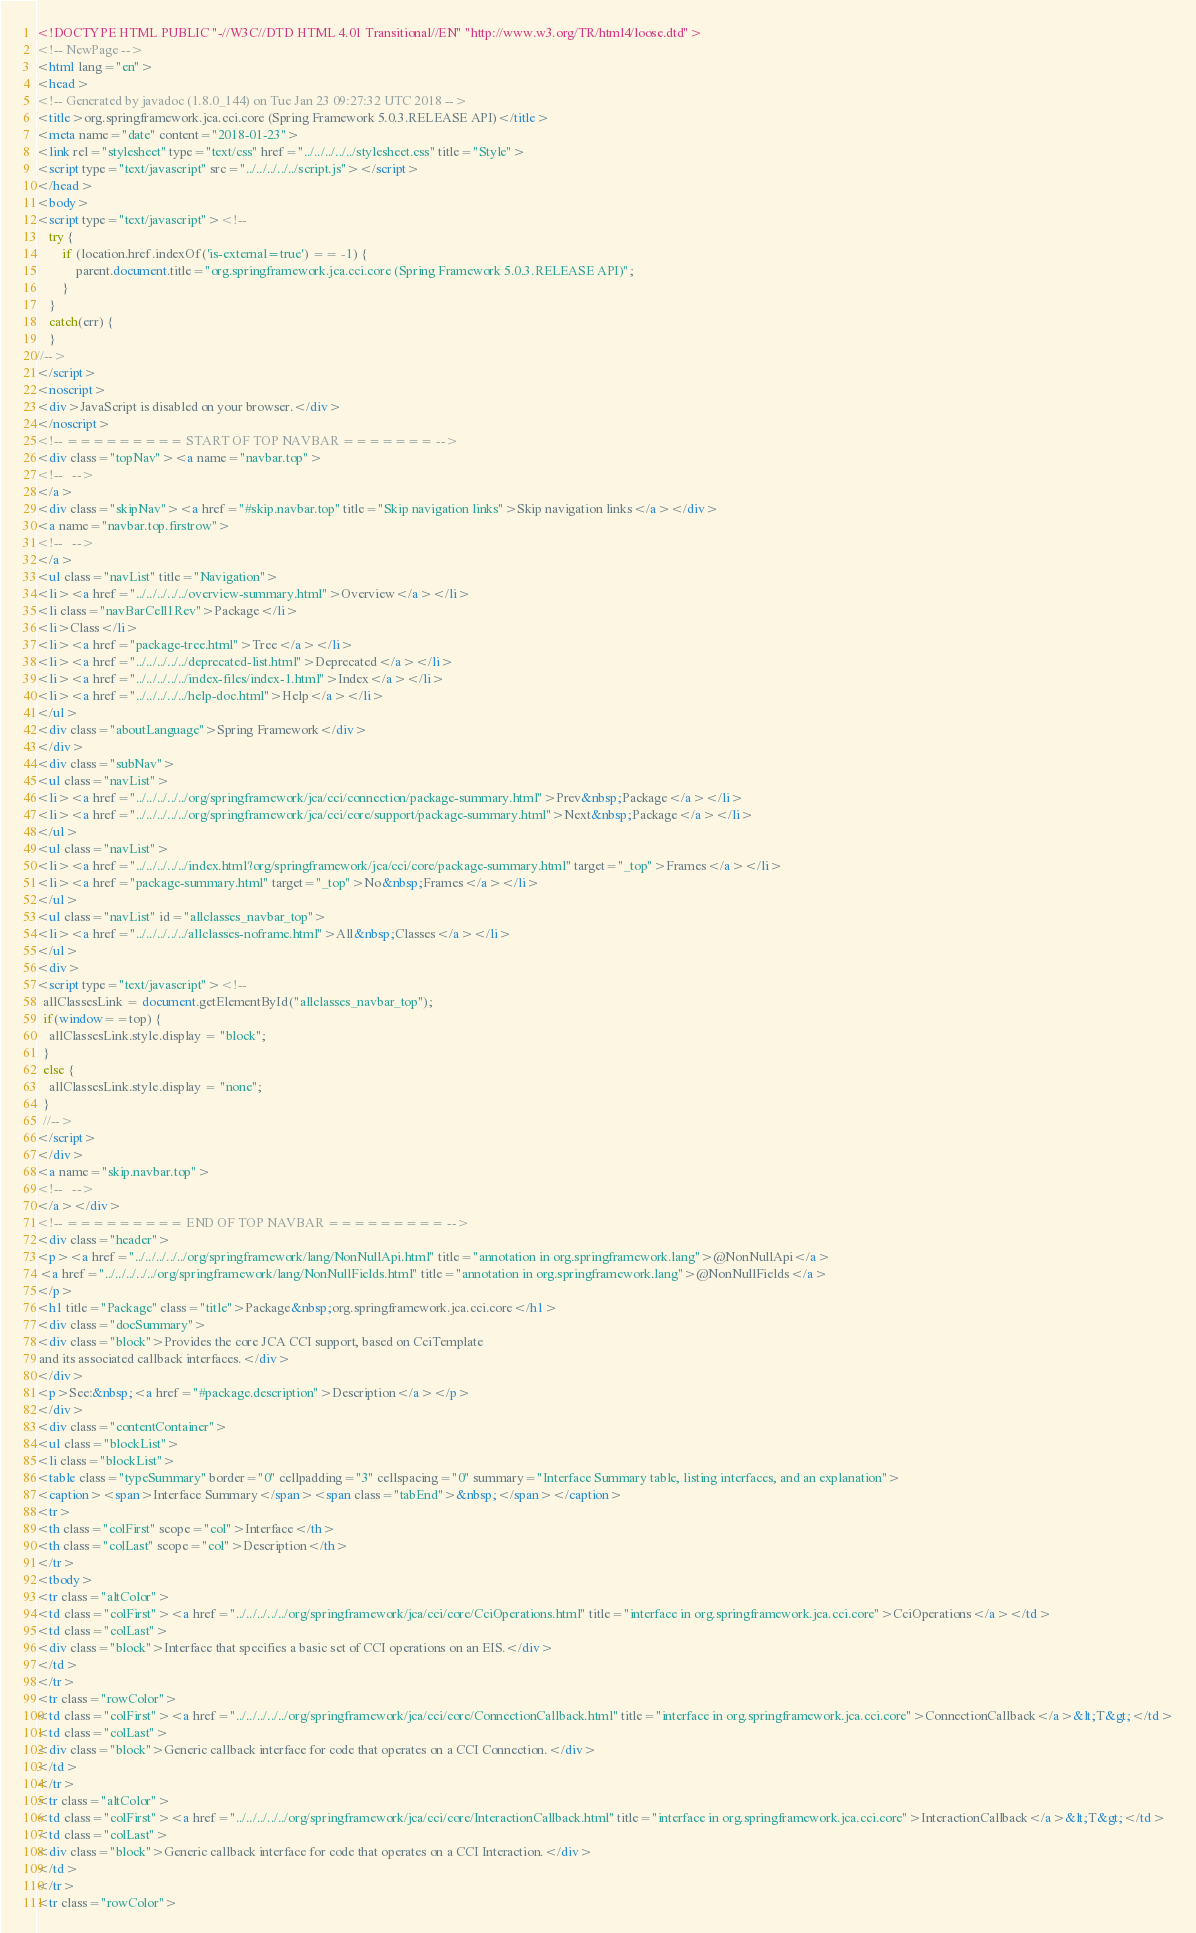<code> <loc_0><loc_0><loc_500><loc_500><_HTML_><!DOCTYPE HTML PUBLIC "-//W3C//DTD HTML 4.01 Transitional//EN" "http://www.w3.org/TR/html4/loose.dtd">
<!-- NewPage -->
<html lang="en">
<head>
<!-- Generated by javadoc (1.8.0_144) on Tue Jan 23 09:27:32 UTC 2018 -->
<title>org.springframework.jca.cci.core (Spring Framework 5.0.3.RELEASE API)</title>
<meta name="date" content="2018-01-23">
<link rel="stylesheet" type="text/css" href="../../../../../stylesheet.css" title="Style">
<script type="text/javascript" src="../../../../../script.js"></script>
</head>
<body>
<script type="text/javascript"><!--
    try {
        if (location.href.indexOf('is-external=true') == -1) {
            parent.document.title="org.springframework.jca.cci.core (Spring Framework 5.0.3.RELEASE API)";
        }
    }
    catch(err) {
    }
//-->
</script>
<noscript>
<div>JavaScript is disabled on your browser.</div>
</noscript>
<!-- ========= START OF TOP NAVBAR ======= -->
<div class="topNav"><a name="navbar.top">
<!--   -->
</a>
<div class="skipNav"><a href="#skip.navbar.top" title="Skip navigation links">Skip navigation links</a></div>
<a name="navbar.top.firstrow">
<!--   -->
</a>
<ul class="navList" title="Navigation">
<li><a href="../../../../../overview-summary.html">Overview</a></li>
<li class="navBarCell1Rev">Package</li>
<li>Class</li>
<li><a href="package-tree.html">Tree</a></li>
<li><a href="../../../../../deprecated-list.html">Deprecated</a></li>
<li><a href="../../../../../index-files/index-1.html">Index</a></li>
<li><a href="../../../../../help-doc.html">Help</a></li>
</ul>
<div class="aboutLanguage">Spring Framework</div>
</div>
<div class="subNav">
<ul class="navList">
<li><a href="../../../../../org/springframework/jca/cci/connection/package-summary.html">Prev&nbsp;Package</a></li>
<li><a href="../../../../../org/springframework/jca/cci/core/support/package-summary.html">Next&nbsp;Package</a></li>
</ul>
<ul class="navList">
<li><a href="../../../../../index.html?org/springframework/jca/cci/core/package-summary.html" target="_top">Frames</a></li>
<li><a href="package-summary.html" target="_top">No&nbsp;Frames</a></li>
</ul>
<ul class="navList" id="allclasses_navbar_top">
<li><a href="../../../../../allclasses-noframe.html">All&nbsp;Classes</a></li>
</ul>
<div>
<script type="text/javascript"><!--
  allClassesLink = document.getElementById("allclasses_navbar_top");
  if(window==top) {
    allClassesLink.style.display = "block";
  }
  else {
    allClassesLink.style.display = "none";
  }
  //-->
</script>
</div>
<a name="skip.navbar.top">
<!--   -->
</a></div>
<!-- ========= END OF TOP NAVBAR ========= -->
<div class="header">
<p><a href="../../../../../org/springframework/lang/NonNullApi.html" title="annotation in org.springframework.lang">@NonNullApi</a>
 <a href="../../../../../org/springframework/lang/NonNullFields.html" title="annotation in org.springframework.lang">@NonNullFields</a>
</p>
<h1 title="Package" class="title">Package&nbsp;org.springframework.jca.cci.core</h1>
<div class="docSummary">
<div class="block">Provides the core JCA CCI support, based on CciTemplate
 and its associated callback interfaces.</div>
</div>
<p>See:&nbsp;<a href="#package.description">Description</a></p>
</div>
<div class="contentContainer">
<ul class="blockList">
<li class="blockList">
<table class="typeSummary" border="0" cellpadding="3" cellspacing="0" summary="Interface Summary table, listing interfaces, and an explanation">
<caption><span>Interface Summary</span><span class="tabEnd">&nbsp;</span></caption>
<tr>
<th class="colFirst" scope="col">Interface</th>
<th class="colLast" scope="col">Description</th>
</tr>
<tbody>
<tr class="altColor">
<td class="colFirst"><a href="../../../../../org/springframework/jca/cci/core/CciOperations.html" title="interface in org.springframework.jca.cci.core">CciOperations</a></td>
<td class="colLast">
<div class="block">Interface that specifies a basic set of CCI operations on an EIS.</div>
</td>
</tr>
<tr class="rowColor">
<td class="colFirst"><a href="../../../../../org/springframework/jca/cci/core/ConnectionCallback.html" title="interface in org.springframework.jca.cci.core">ConnectionCallback</a>&lt;T&gt;</td>
<td class="colLast">
<div class="block">Generic callback interface for code that operates on a CCI Connection.</div>
</td>
</tr>
<tr class="altColor">
<td class="colFirst"><a href="../../../../../org/springframework/jca/cci/core/InteractionCallback.html" title="interface in org.springframework.jca.cci.core">InteractionCallback</a>&lt;T&gt;</td>
<td class="colLast">
<div class="block">Generic callback interface for code that operates on a CCI Interaction.</div>
</td>
</tr>
<tr class="rowColor"></code> 